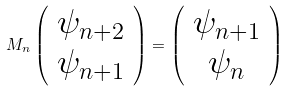<formula> <loc_0><loc_0><loc_500><loc_500>M _ { n } \left ( \begin{array} { c } \psi _ { n + 2 } \\ \psi _ { n + 1 } \\ \end{array} \right ) = \left ( \begin{array} { c } \psi _ { n + 1 } \\ \psi _ { n } \\ \end{array} \right )</formula> 